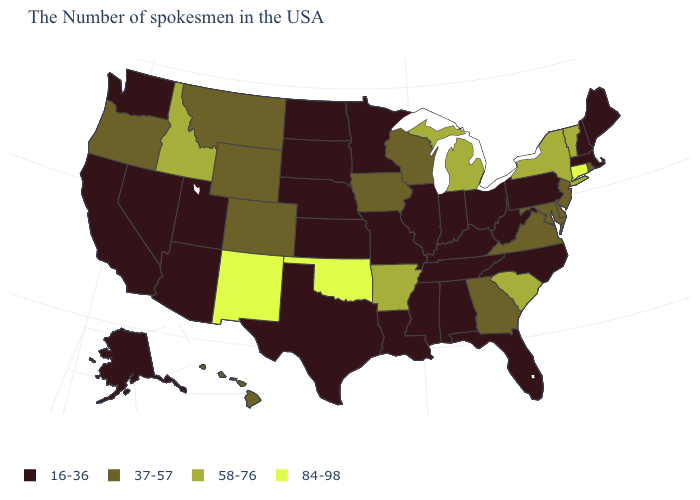What is the value of Idaho?
Be succinct. 58-76. What is the value of West Virginia?
Write a very short answer. 16-36. Which states hav the highest value in the MidWest?
Give a very brief answer. Michigan. What is the value of Maryland?
Give a very brief answer. 37-57. Is the legend a continuous bar?
Keep it brief. No. Which states have the lowest value in the USA?
Answer briefly. Maine, Massachusetts, New Hampshire, Pennsylvania, North Carolina, West Virginia, Ohio, Florida, Kentucky, Indiana, Alabama, Tennessee, Illinois, Mississippi, Louisiana, Missouri, Minnesota, Kansas, Nebraska, Texas, South Dakota, North Dakota, Utah, Arizona, Nevada, California, Washington, Alaska. Among the states that border Kentucky , does Virginia have the lowest value?
Be succinct. No. Which states hav the highest value in the South?
Be succinct. Oklahoma. Does Florida have the lowest value in the USA?
Concise answer only. Yes. What is the value of Kentucky?
Short answer required. 16-36. What is the value of Georgia?
Give a very brief answer. 37-57. What is the value of Alaska?
Concise answer only. 16-36. What is the value of Ohio?
Be succinct. 16-36. What is the value of Idaho?
Quick response, please. 58-76. What is the value of Iowa?
Concise answer only. 37-57. 